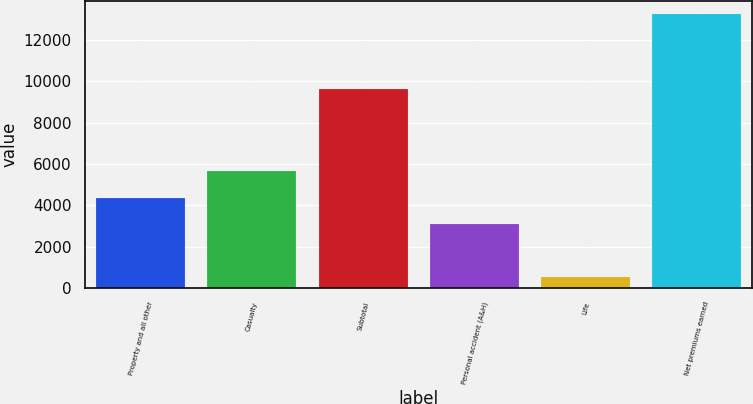Convert chart to OTSL. <chart><loc_0><loc_0><loc_500><loc_500><bar_chart><fcel>Property and all other<fcel>Casualty<fcel>Subtotal<fcel>Personal accident (A&H)<fcel>Life<fcel>Net premiums earned<nl><fcel>4374.3<fcel>5645.6<fcel>9610<fcel>3103<fcel>527<fcel>13240<nl></chart> 